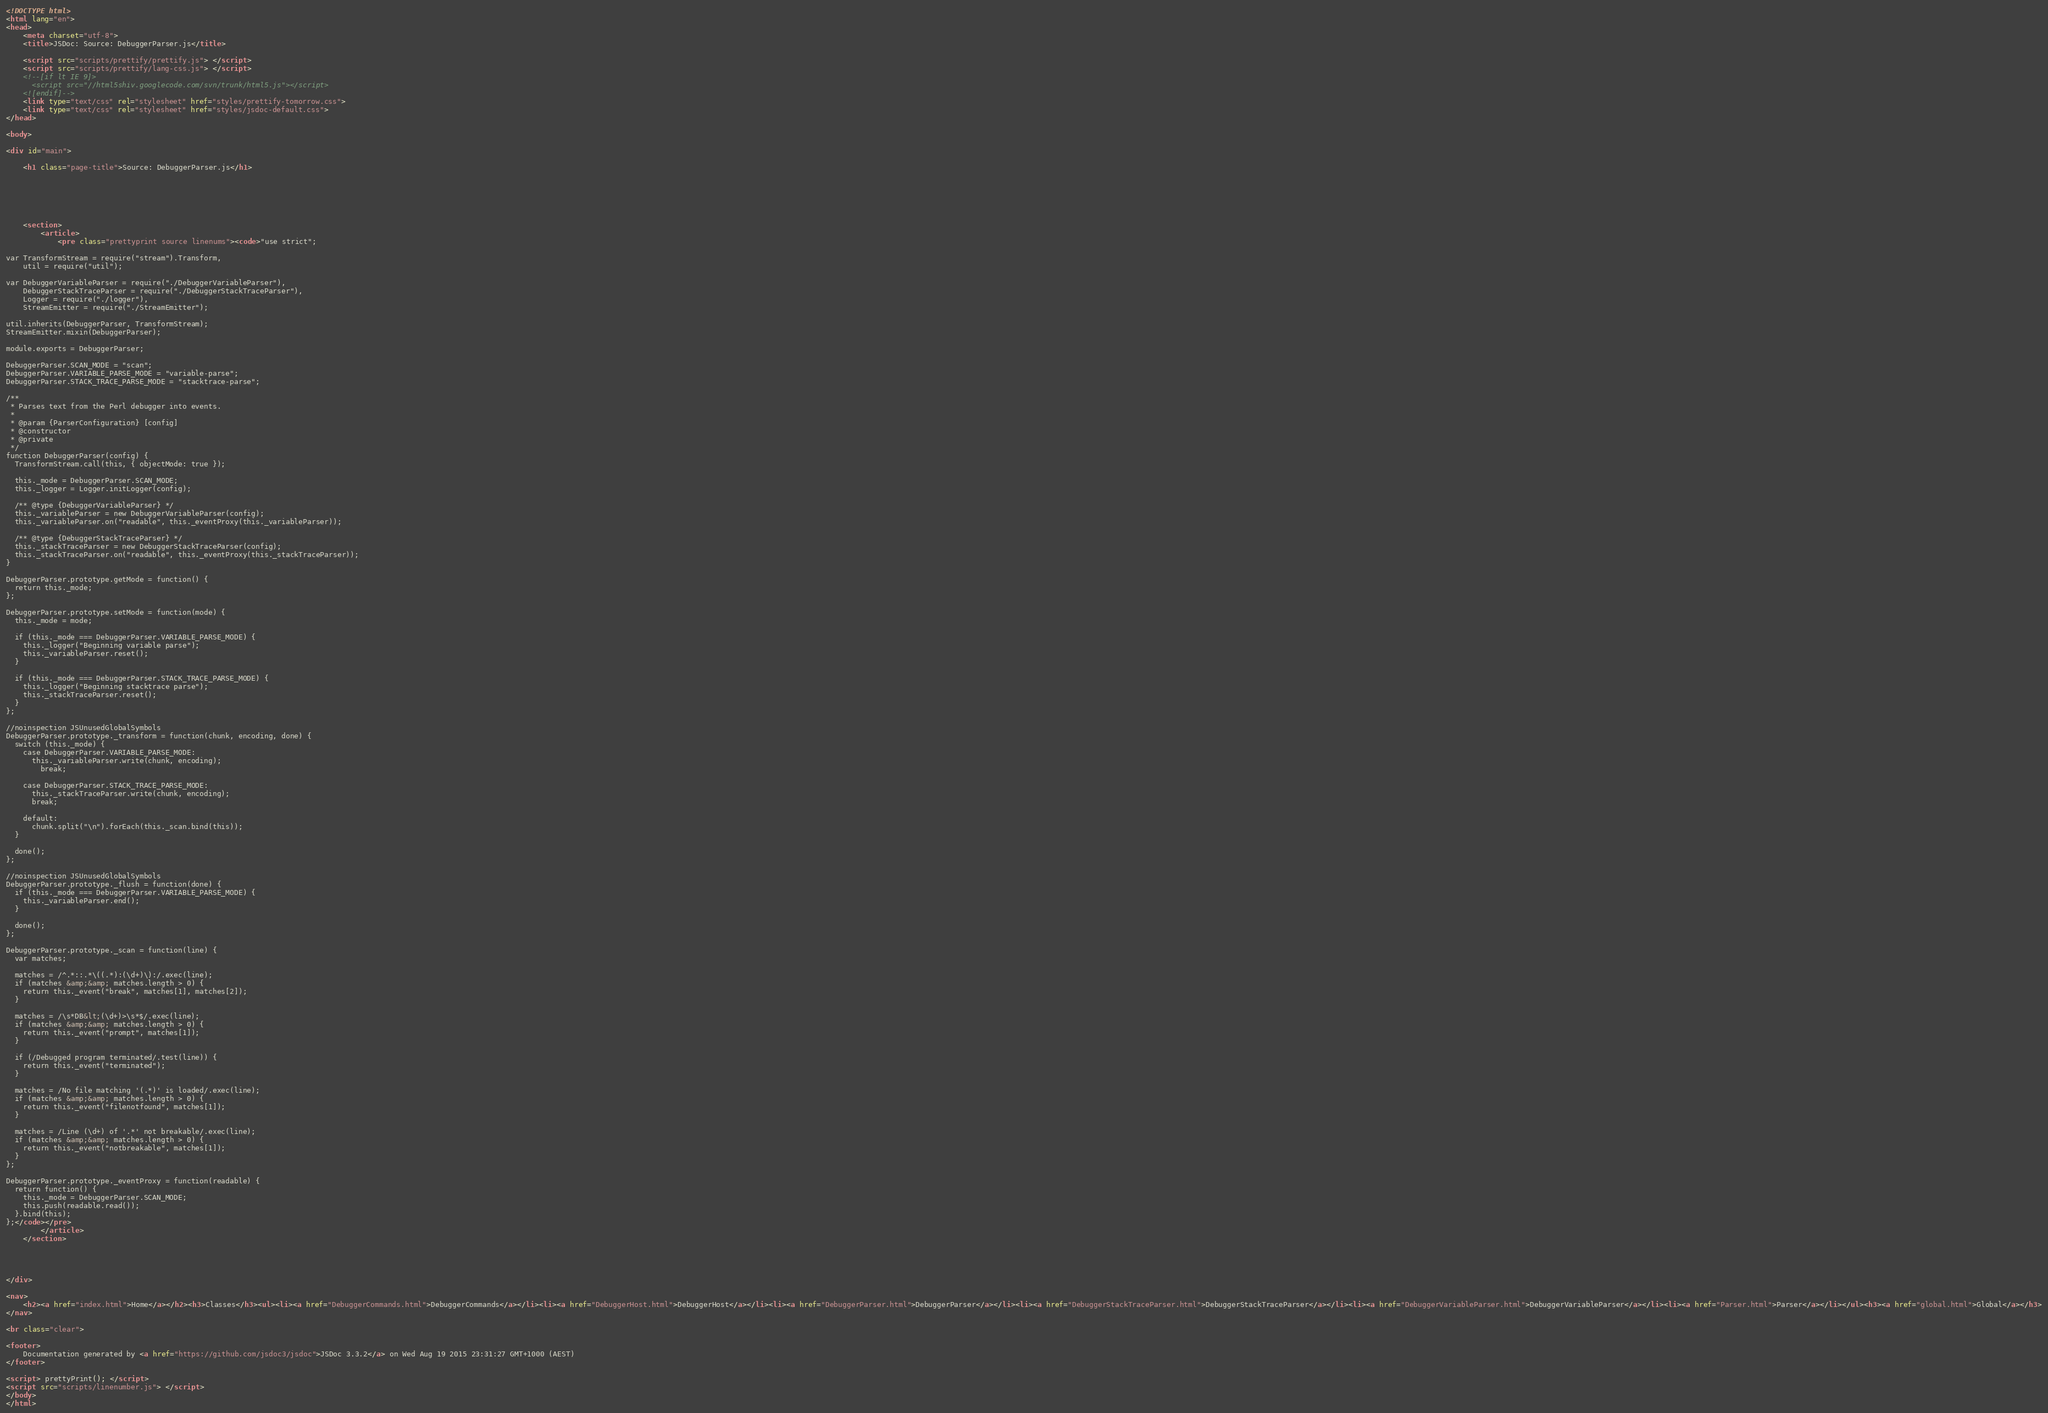Convert code to text. <code><loc_0><loc_0><loc_500><loc_500><_HTML_><!DOCTYPE html>
<html lang="en">
<head>
    <meta charset="utf-8">
    <title>JSDoc: Source: DebuggerParser.js</title>

    <script src="scripts/prettify/prettify.js"> </script>
    <script src="scripts/prettify/lang-css.js"> </script>
    <!--[if lt IE 9]>
      <script src="//html5shiv.googlecode.com/svn/trunk/html5.js"></script>
    <![endif]-->
    <link type="text/css" rel="stylesheet" href="styles/prettify-tomorrow.css">
    <link type="text/css" rel="stylesheet" href="styles/jsdoc-default.css">
</head>

<body>

<div id="main">

    <h1 class="page-title">Source: DebuggerParser.js</h1>

    



    
    <section>
        <article>
            <pre class="prettyprint source linenums"><code>"use strict";

var TransformStream = require("stream").Transform,
    util = require("util");

var DebuggerVariableParser = require("./DebuggerVariableParser"),
    DebuggerStackTraceParser = require("./DebuggerStackTraceParser"),
    Logger = require("./logger"),
    StreamEmitter = require("./StreamEmitter");

util.inherits(DebuggerParser, TransformStream);
StreamEmitter.mixin(DebuggerParser);

module.exports = DebuggerParser;

DebuggerParser.SCAN_MODE = "scan";
DebuggerParser.VARIABLE_PARSE_MODE = "variable-parse";
DebuggerParser.STACK_TRACE_PARSE_MODE = "stacktrace-parse";

/**
 * Parses text from the Perl debugger into events.
 *
 * @param {ParserConfiguration} [config]
 * @constructor
 * @private
 */
function DebuggerParser(config) {
  TransformStream.call(this, { objectMode: true });

  this._mode = DebuggerParser.SCAN_MODE;
  this._logger = Logger.initLogger(config);

  /** @type {DebuggerVariableParser} */
  this._variableParser = new DebuggerVariableParser(config);
  this._variableParser.on("readable", this._eventProxy(this._variableParser));

  /** @type {DebuggerStackTraceParser} */
  this._stackTraceParser = new DebuggerStackTraceParser(config);
  this._stackTraceParser.on("readable", this._eventProxy(this._stackTraceParser));
}

DebuggerParser.prototype.getMode = function() {
  return this._mode;
};

DebuggerParser.prototype.setMode = function(mode) {
  this._mode = mode;

  if (this._mode === DebuggerParser.VARIABLE_PARSE_MODE) {
    this._logger("Beginning variable parse");
    this._variableParser.reset();
  }

  if (this._mode === DebuggerParser.STACK_TRACE_PARSE_MODE) {
    this._logger("Beginning stacktrace parse");
    this._stackTraceParser.reset();
  }
};

//noinspection JSUnusedGlobalSymbols
DebuggerParser.prototype._transform = function(chunk, encoding, done) {
  switch (this._mode) {
    case DebuggerParser.VARIABLE_PARSE_MODE:
      this._variableParser.write(chunk, encoding);
        break;

    case DebuggerParser.STACK_TRACE_PARSE_MODE:
      this._stackTraceParser.write(chunk, encoding);
      break;

    default:
      chunk.split("\n").forEach(this._scan.bind(this));
  }

  done();
};

//noinspection JSUnusedGlobalSymbols
DebuggerParser.prototype._flush = function(done) {
  if (this._mode === DebuggerParser.VARIABLE_PARSE_MODE) {
    this._variableParser.end();
  }

  done();
};

DebuggerParser.prototype._scan = function(line) {
  var matches;

  matches = /^.*::.*\((.*):(\d+)\):/.exec(line);
  if (matches &amp;&amp; matches.length > 0) {
    return this._event("break", matches[1], matches[2]);
  }

  matches = /\s*DB&lt;(\d+)>\s*$/.exec(line);
  if (matches &amp;&amp; matches.length > 0) {
    return this._event("prompt", matches[1]);
  }

  if (/Debugged program terminated/.test(line)) {
    return this._event("terminated");
  }

  matches = /No file matching '(.*)' is loaded/.exec(line);
  if (matches &amp;&amp; matches.length > 0) {
    return this._event("filenotfound", matches[1]);
  }

  matches = /Line (\d+) of '.*' not breakable/.exec(line);
  if (matches &amp;&amp; matches.length > 0) {
    return this._event("notbreakable", matches[1]);
  }
};

DebuggerParser.prototype._eventProxy = function(readable) {
  return function() {
    this._mode = DebuggerParser.SCAN_MODE;
    this.push(readable.read());
  }.bind(this);
};</code></pre>
        </article>
    </section>




</div>

<nav>
    <h2><a href="index.html">Home</a></h2><h3>Classes</h3><ul><li><a href="DebuggerCommands.html">DebuggerCommands</a></li><li><a href="DebuggerHost.html">DebuggerHost</a></li><li><a href="DebuggerParser.html">DebuggerParser</a></li><li><a href="DebuggerStackTraceParser.html">DebuggerStackTraceParser</a></li><li><a href="DebuggerVariableParser.html">DebuggerVariableParser</a></li><li><a href="Parser.html">Parser</a></li></ul><h3><a href="global.html">Global</a></h3>
</nav>

<br class="clear">

<footer>
    Documentation generated by <a href="https://github.com/jsdoc3/jsdoc">JSDoc 3.3.2</a> on Wed Aug 19 2015 23:31:27 GMT+1000 (AEST)
</footer>

<script> prettyPrint(); </script>
<script src="scripts/linenumber.js"> </script>
</body>
</html>
</code> 